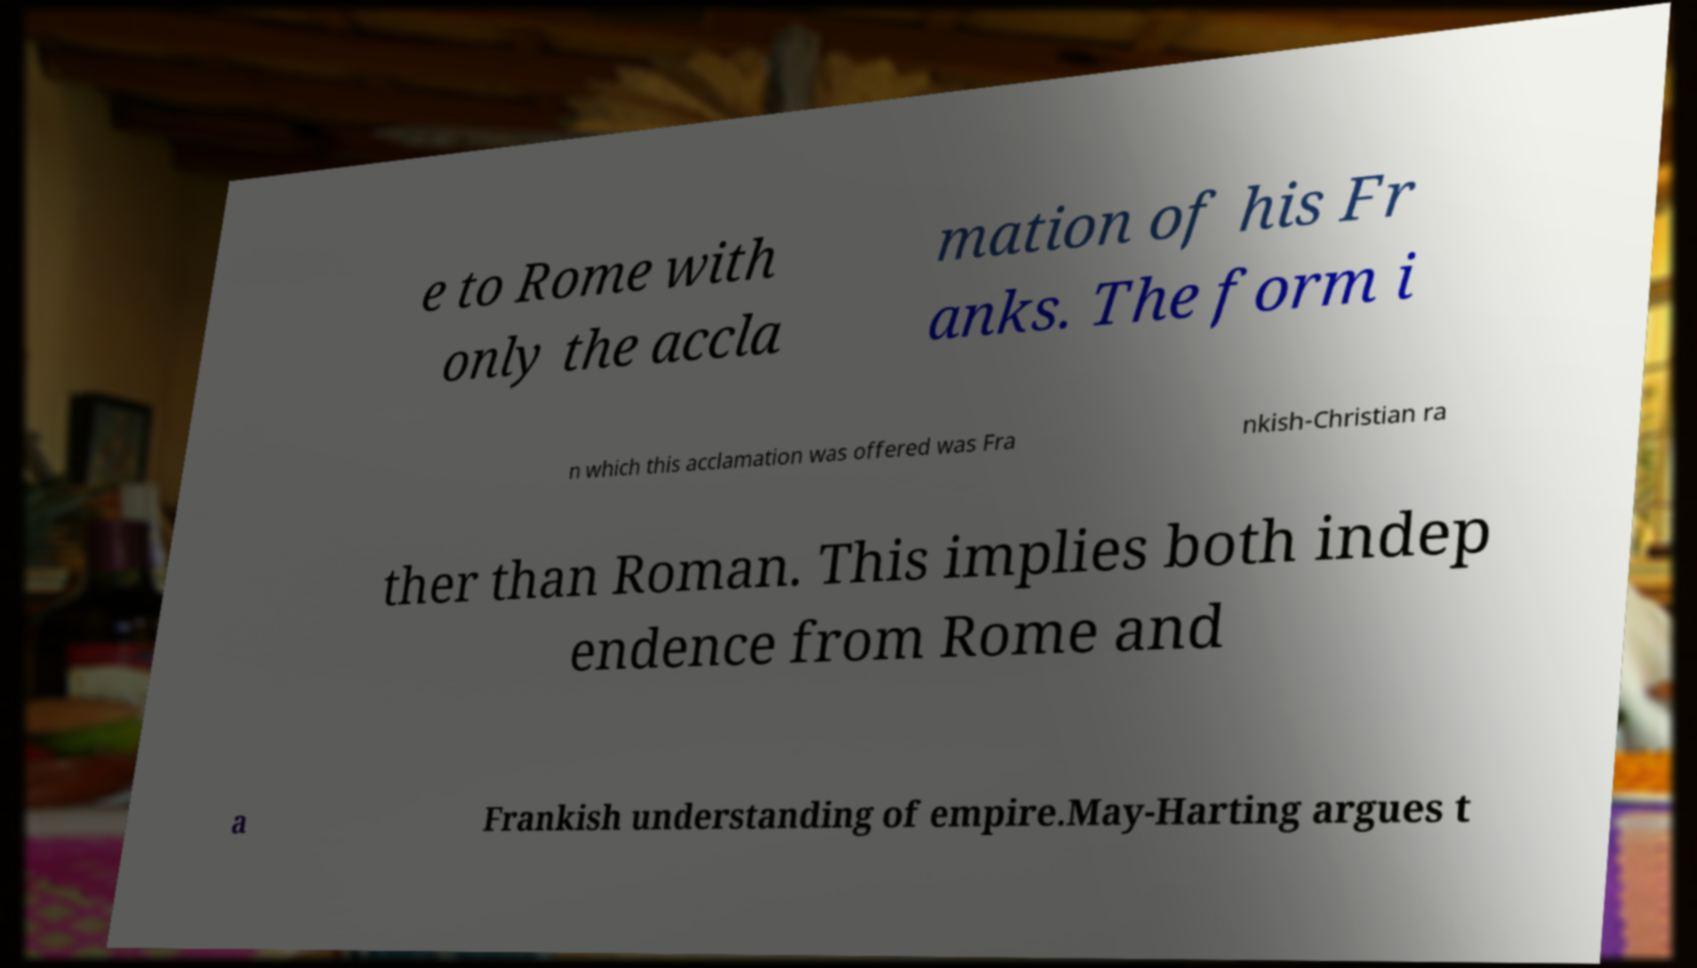Can you accurately transcribe the text from the provided image for me? e to Rome with only the accla mation of his Fr anks. The form i n which this acclamation was offered was Fra nkish-Christian ra ther than Roman. This implies both indep endence from Rome and a Frankish understanding of empire.May-Harting argues t 